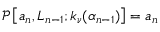Convert formula to latex. <formula><loc_0><loc_0><loc_500><loc_500>\mathcal { P } \left [ a _ { n } , L _ { n - 1 } ; k _ { \nu } ( \alpha _ { n - 1 } ) \right ] = a _ { n }</formula> 